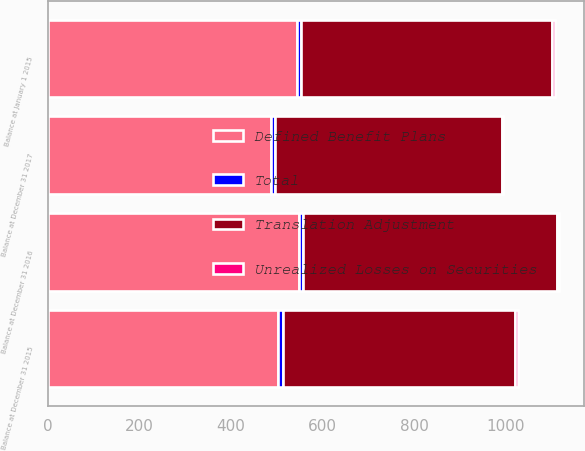Convert chart. <chart><loc_0><loc_0><loc_500><loc_500><stacked_bar_chart><ecel><fcel>Balance at January 1 2015<fcel>Balance at December 31 2015<fcel>Balance at December 31 2016<fcel>Balance at December 31 2017<nl><fcel>Translation Adjustment<fcel>548<fcel>507<fcel>554<fcel>494<nl><fcel>Unrealized Losses on Securities<fcel>6<fcel>6<fcel>4<fcel>3<nl><fcel>Total<fcel>10<fcel>10<fcel>10<fcel>10<nl><fcel>Defined Benefit Plans<fcel>544<fcel>503<fcel>548<fcel>487<nl></chart> 